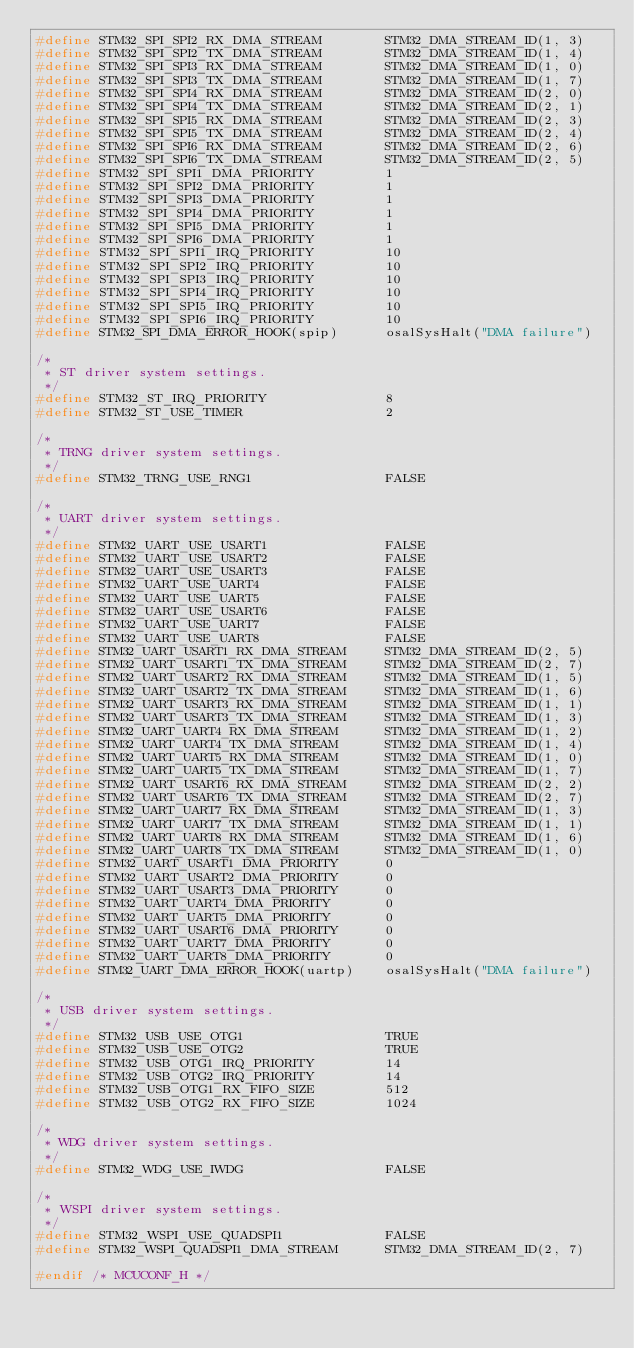Convert code to text. <code><loc_0><loc_0><loc_500><loc_500><_C_>#define STM32_SPI_SPI2_RX_DMA_STREAM        STM32_DMA_STREAM_ID(1, 3)
#define STM32_SPI_SPI2_TX_DMA_STREAM        STM32_DMA_STREAM_ID(1, 4)
#define STM32_SPI_SPI3_RX_DMA_STREAM        STM32_DMA_STREAM_ID(1, 0)
#define STM32_SPI_SPI3_TX_DMA_STREAM        STM32_DMA_STREAM_ID(1, 7)
#define STM32_SPI_SPI4_RX_DMA_STREAM        STM32_DMA_STREAM_ID(2, 0)
#define STM32_SPI_SPI4_TX_DMA_STREAM        STM32_DMA_STREAM_ID(2, 1)
#define STM32_SPI_SPI5_RX_DMA_STREAM        STM32_DMA_STREAM_ID(2, 3)
#define STM32_SPI_SPI5_TX_DMA_STREAM        STM32_DMA_STREAM_ID(2, 4)
#define STM32_SPI_SPI6_RX_DMA_STREAM        STM32_DMA_STREAM_ID(2, 6)
#define STM32_SPI_SPI6_TX_DMA_STREAM        STM32_DMA_STREAM_ID(2, 5)
#define STM32_SPI_SPI1_DMA_PRIORITY         1
#define STM32_SPI_SPI2_DMA_PRIORITY         1
#define STM32_SPI_SPI3_DMA_PRIORITY         1
#define STM32_SPI_SPI4_DMA_PRIORITY         1
#define STM32_SPI_SPI5_DMA_PRIORITY         1
#define STM32_SPI_SPI6_DMA_PRIORITY         1
#define STM32_SPI_SPI1_IRQ_PRIORITY         10
#define STM32_SPI_SPI2_IRQ_PRIORITY         10
#define STM32_SPI_SPI3_IRQ_PRIORITY         10
#define STM32_SPI_SPI4_IRQ_PRIORITY         10
#define STM32_SPI_SPI5_IRQ_PRIORITY         10
#define STM32_SPI_SPI6_IRQ_PRIORITY         10
#define STM32_SPI_DMA_ERROR_HOOK(spip)      osalSysHalt("DMA failure")

/*
 * ST driver system settings.
 */
#define STM32_ST_IRQ_PRIORITY               8
#define STM32_ST_USE_TIMER                  2

/*
 * TRNG driver system settings.
 */
#define STM32_TRNG_USE_RNG1                 FALSE

/*
 * UART driver system settings.
 */
#define STM32_UART_USE_USART1               FALSE
#define STM32_UART_USE_USART2               FALSE
#define STM32_UART_USE_USART3               FALSE
#define STM32_UART_USE_UART4                FALSE
#define STM32_UART_USE_UART5                FALSE
#define STM32_UART_USE_USART6               FALSE
#define STM32_UART_USE_UART7                FALSE
#define STM32_UART_USE_UART8                FALSE
#define STM32_UART_USART1_RX_DMA_STREAM     STM32_DMA_STREAM_ID(2, 5)
#define STM32_UART_USART1_TX_DMA_STREAM     STM32_DMA_STREAM_ID(2, 7)
#define STM32_UART_USART2_RX_DMA_STREAM     STM32_DMA_STREAM_ID(1, 5)
#define STM32_UART_USART2_TX_DMA_STREAM     STM32_DMA_STREAM_ID(1, 6)
#define STM32_UART_USART3_RX_DMA_STREAM     STM32_DMA_STREAM_ID(1, 1)
#define STM32_UART_USART3_TX_DMA_STREAM     STM32_DMA_STREAM_ID(1, 3)
#define STM32_UART_UART4_RX_DMA_STREAM      STM32_DMA_STREAM_ID(1, 2)
#define STM32_UART_UART4_TX_DMA_STREAM      STM32_DMA_STREAM_ID(1, 4)
#define STM32_UART_UART5_RX_DMA_STREAM      STM32_DMA_STREAM_ID(1, 0)
#define STM32_UART_UART5_TX_DMA_STREAM      STM32_DMA_STREAM_ID(1, 7)
#define STM32_UART_USART6_RX_DMA_STREAM     STM32_DMA_STREAM_ID(2, 2)
#define STM32_UART_USART6_TX_DMA_STREAM     STM32_DMA_STREAM_ID(2, 7)
#define STM32_UART_UART7_RX_DMA_STREAM      STM32_DMA_STREAM_ID(1, 3)
#define STM32_UART_UART7_TX_DMA_STREAM      STM32_DMA_STREAM_ID(1, 1)
#define STM32_UART_UART8_RX_DMA_STREAM      STM32_DMA_STREAM_ID(1, 6)
#define STM32_UART_UART8_TX_DMA_STREAM      STM32_DMA_STREAM_ID(1, 0)
#define STM32_UART_USART1_DMA_PRIORITY      0
#define STM32_UART_USART2_DMA_PRIORITY      0
#define STM32_UART_USART3_DMA_PRIORITY      0
#define STM32_UART_UART4_DMA_PRIORITY       0
#define STM32_UART_UART5_DMA_PRIORITY       0
#define STM32_UART_USART6_DMA_PRIORITY      0
#define STM32_UART_UART7_DMA_PRIORITY       0
#define STM32_UART_UART8_DMA_PRIORITY       0
#define STM32_UART_DMA_ERROR_HOOK(uartp)    osalSysHalt("DMA failure")

/*
 * USB driver system settings.
 */
#define STM32_USB_USE_OTG1                  TRUE
#define STM32_USB_USE_OTG2                  TRUE
#define STM32_USB_OTG1_IRQ_PRIORITY         14
#define STM32_USB_OTG2_IRQ_PRIORITY         14
#define STM32_USB_OTG1_RX_FIFO_SIZE         512
#define STM32_USB_OTG2_RX_FIFO_SIZE         1024

/*
 * WDG driver system settings.
 */
#define STM32_WDG_USE_IWDG                  FALSE

/*
 * WSPI driver system settings.
 */
#define STM32_WSPI_USE_QUADSPI1             FALSE
#define STM32_WSPI_QUADSPI1_DMA_STREAM      STM32_DMA_STREAM_ID(2, 7)

#endif /* MCUCONF_H */
</code> 